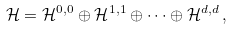Convert formula to latex. <formula><loc_0><loc_0><loc_500><loc_500>\mathcal { H } = \mathcal { H } ^ { 0 , 0 } \oplus \mathcal { H } ^ { 1 , 1 } \oplus \dots \oplus \mathcal { H } ^ { d , d } \, ,</formula> 